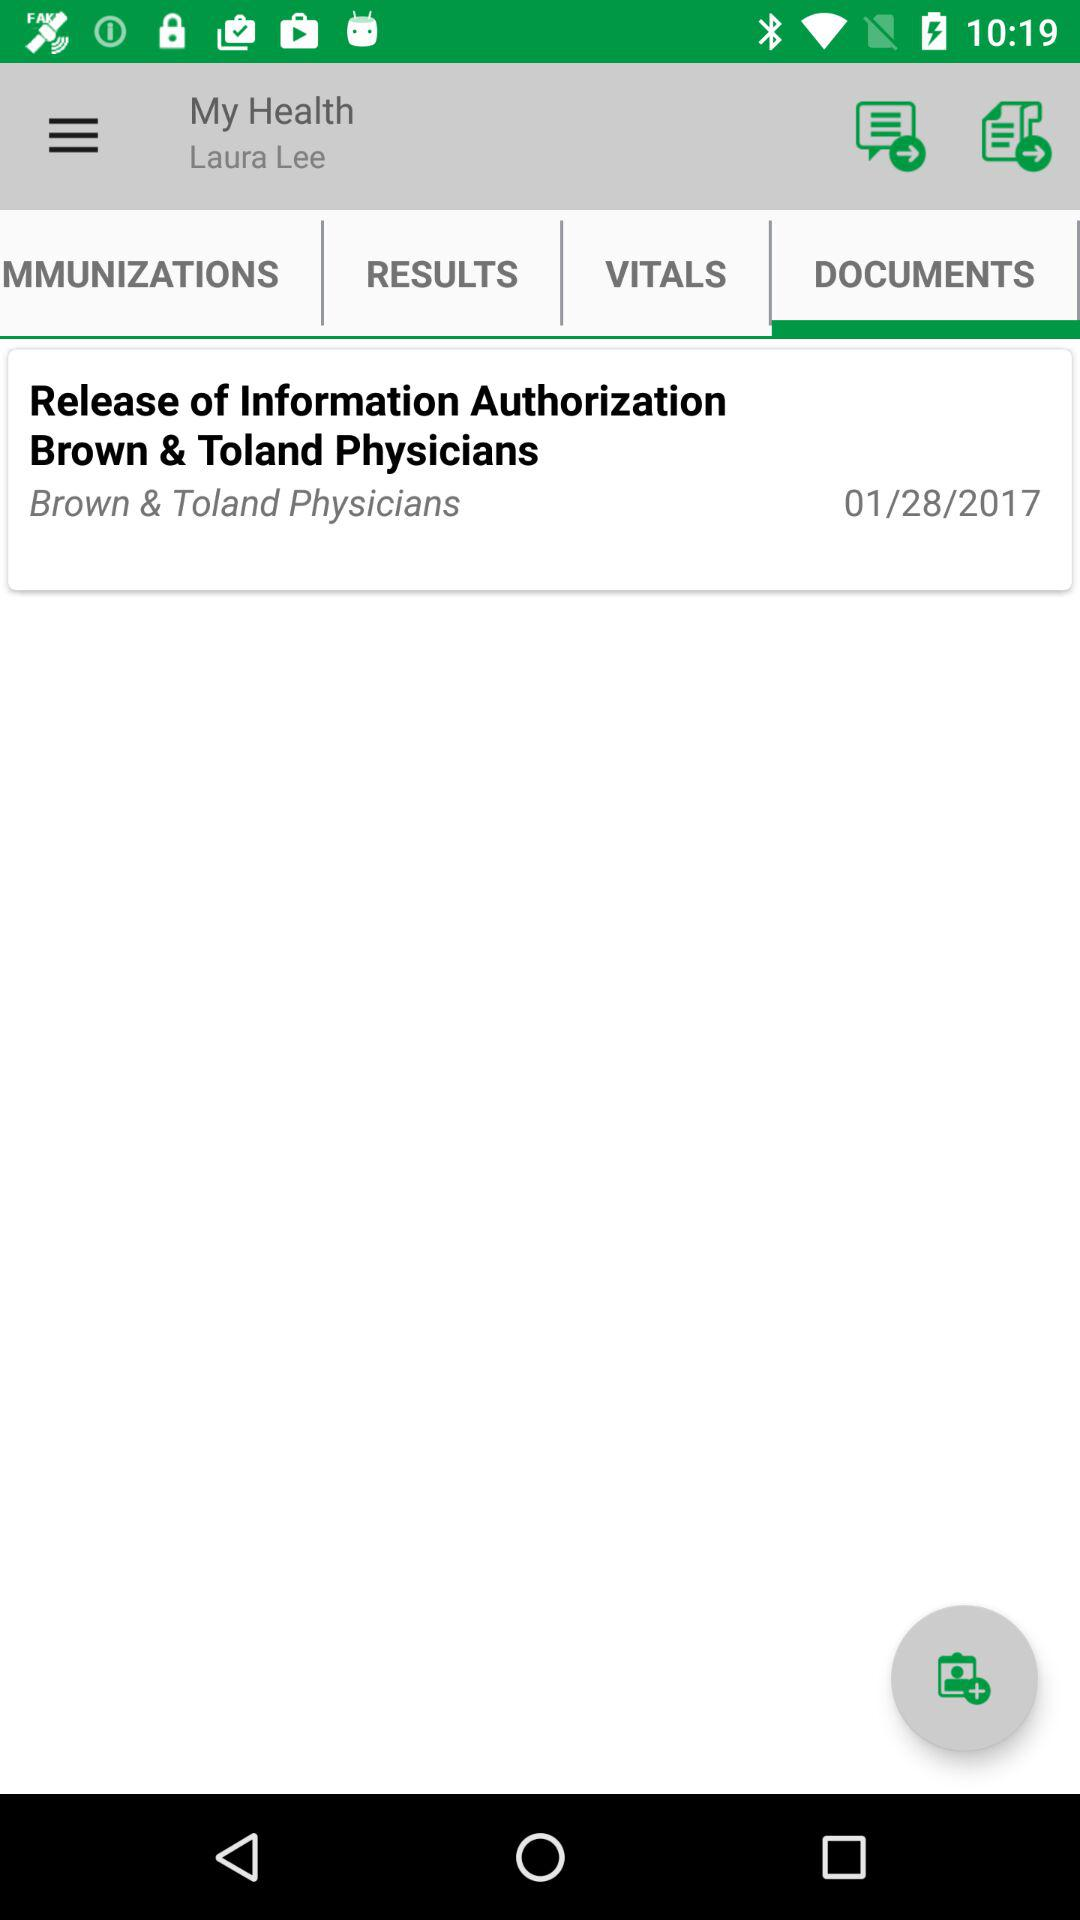Which tab is selected? The selected tab is "DOCUMENTS". 